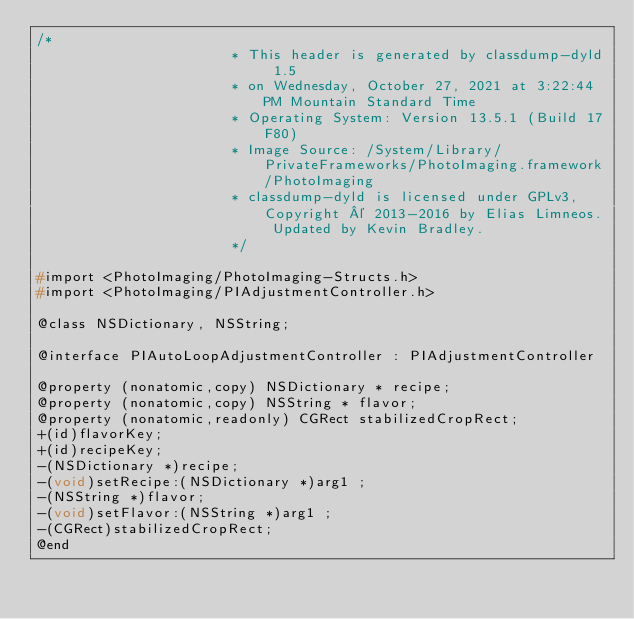Convert code to text. <code><loc_0><loc_0><loc_500><loc_500><_C_>/*
                       * This header is generated by classdump-dyld 1.5
                       * on Wednesday, October 27, 2021 at 3:22:44 PM Mountain Standard Time
                       * Operating System: Version 13.5.1 (Build 17F80)
                       * Image Source: /System/Library/PrivateFrameworks/PhotoImaging.framework/PhotoImaging
                       * classdump-dyld is licensed under GPLv3, Copyright © 2013-2016 by Elias Limneos. Updated by Kevin Bradley.
                       */

#import <PhotoImaging/PhotoImaging-Structs.h>
#import <PhotoImaging/PIAdjustmentController.h>

@class NSDictionary, NSString;

@interface PIAutoLoopAdjustmentController : PIAdjustmentController

@property (nonatomic,copy) NSDictionary * recipe; 
@property (nonatomic,copy) NSString * flavor; 
@property (nonatomic,readonly) CGRect stabilizedCropRect; 
+(id)flavorKey;
+(id)recipeKey;
-(NSDictionary *)recipe;
-(void)setRecipe:(NSDictionary *)arg1 ;
-(NSString *)flavor;
-(void)setFlavor:(NSString *)arg1 ;
-(CGRect)stabilizedCropRect;
@end

</code> 